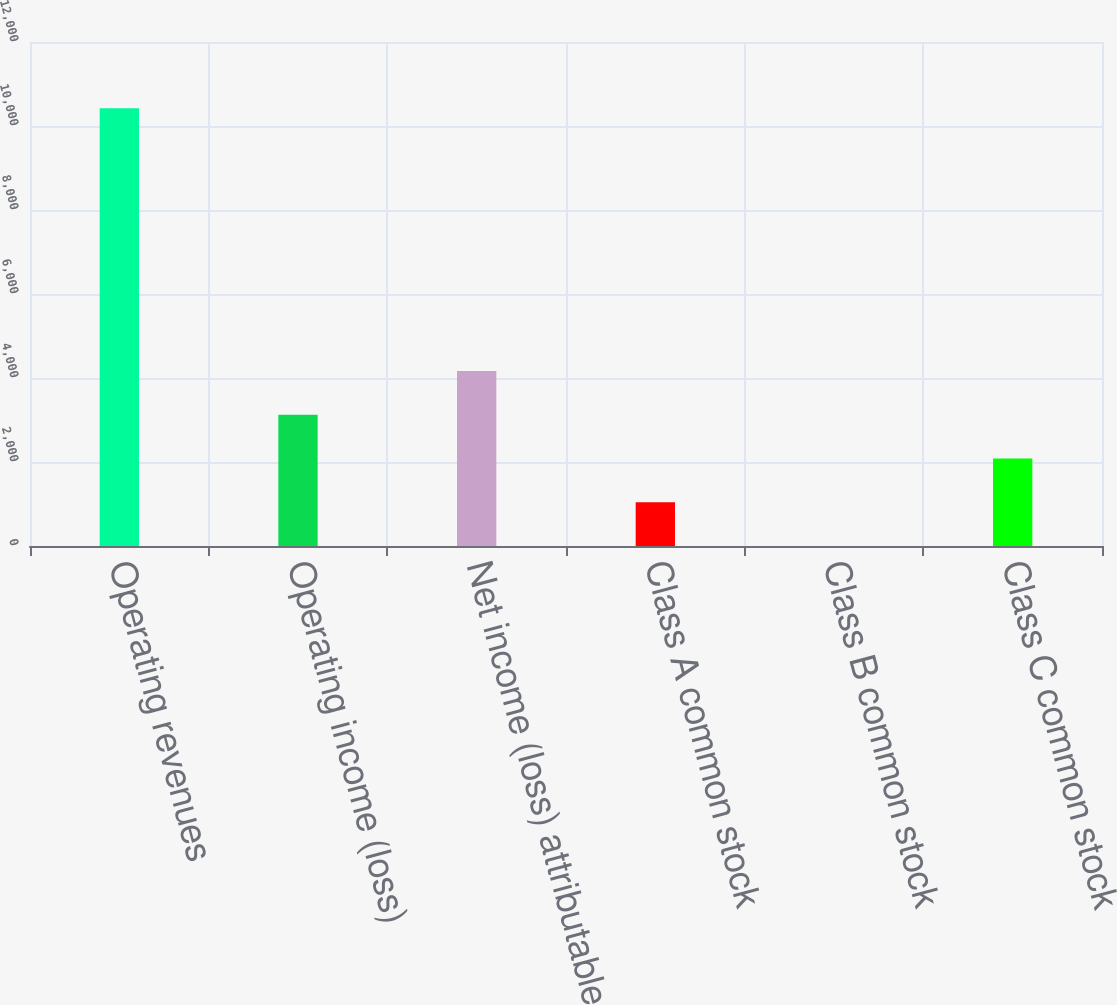Convert chart to OTSL. <chart><loc_0><loc_0><loc_500><loc_500><bar_chart><fcel>Operating revenues<fcel>Operating income (loss)<fcel>Net income (loss) attributable<fcel>Class A common stock<fcel>Class B common stock<fcel>Class C common stock<nl><fcel>10421<fcel>3127.28<fcel>4169.24<fcel>1043.36<fcel>1.4<fcel>2085.32<nl></chart> 